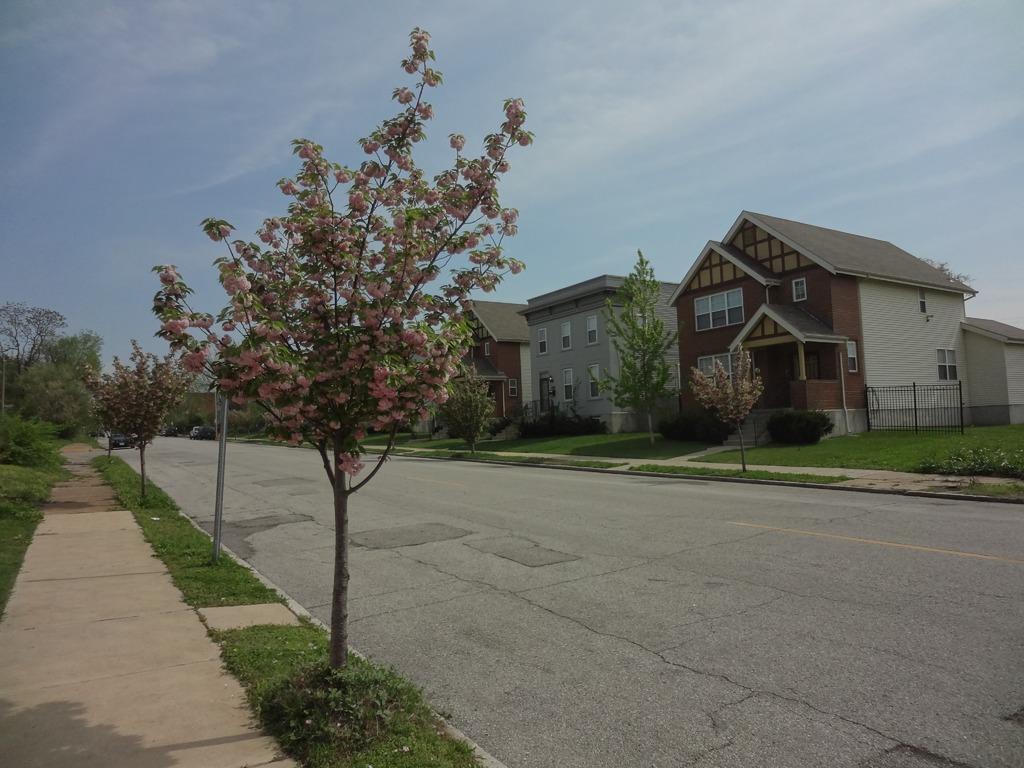How would you summarize this image in a sentence or two? In this picture we can see brown color house with roof tiles. In the front center there is a road and on the left side we can see the small tree. 